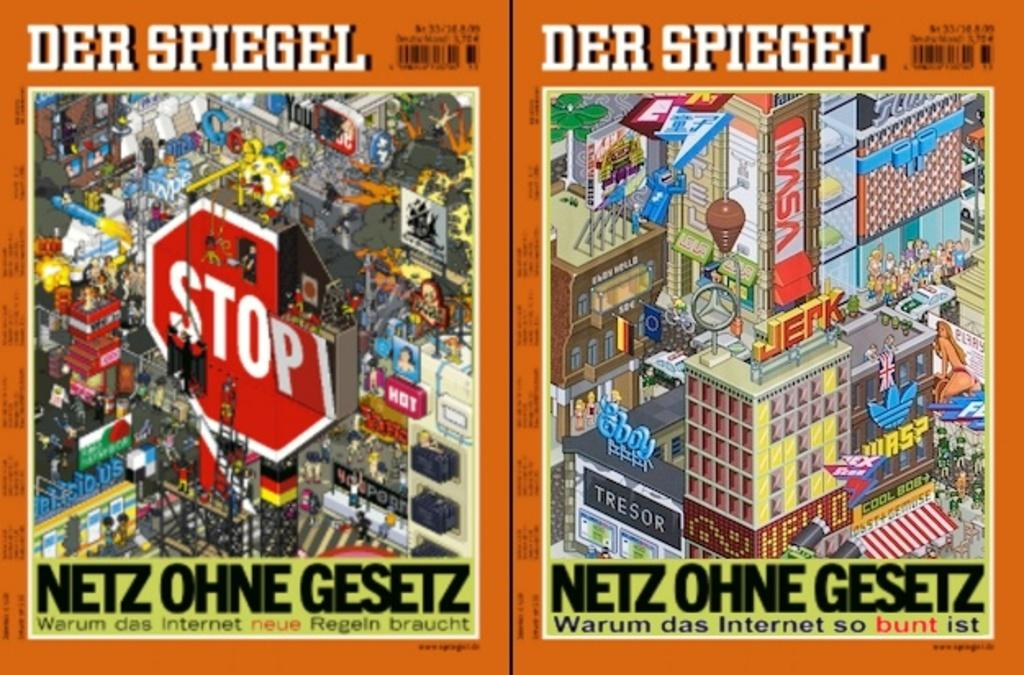<image>
Present a compact description of the photo's key features. A magazine called Der Spiegel has a stop sign and colorful buildings on it. 